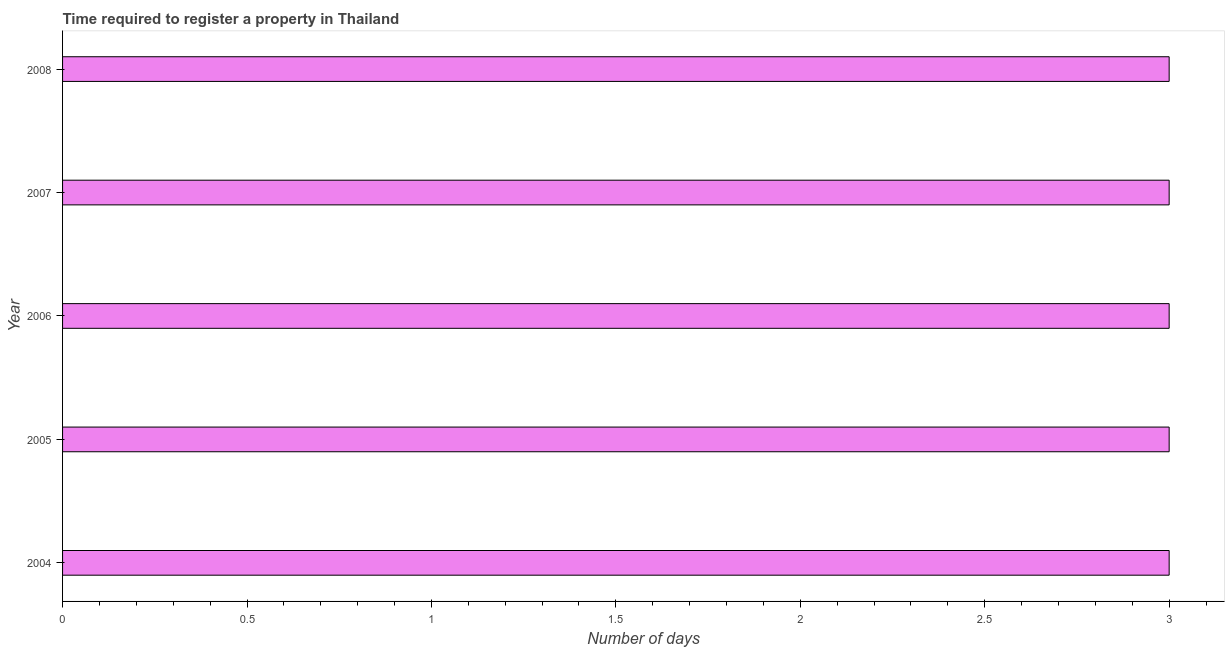What is the title of the graph?
Make the answer very short. Time required to register a property in Thailand. What is the label or title of the X-axis?
Give a very brief answer. Number of days. What is the label or title of the Y-axis?
Offer a very short reply. Year. What is the number of days required to register property in 2006?
Your answer should be compact. 3. Across all years, what is the maximum number of days required to register property?
Ensure brevity in your answer.  3. In which year was the number of days required to register property maximum?
Make the answer very short. 2004. In which year was the number of days required to register property minimum?
Ensure brevity in your answer.  2004. What is the difference between the number of days required to register property in 2005 and 2007?
Your answer should be very brief. 0. What is the median number of days required to register property?
Offer a very short reply. 3. Do a majority of the years between 2007 and 2004 (inclusive) have number of days required to register property greater than 2.8 days?
Keep it short and to the point. Yes. Is the number of days required to register property in 2005 less than that in 2008?
Your answer should be compact. No. Is the difference between the number of days required to register property in 2004 and 2006 greater than the difference between any two years?
Provide a short and direct response. Yes. What is the difference between the highest and the second highest number of days required to register property?
Your answer should be very brief. 0. What is the difference between the highest and the lowest number of days required to register property?
Your answer should be compact. 0. How many years are there in the graph?
Give a very brief answer. 5. What is the difference between two consecutive major ticks on the X-axis?
Offer a very short reply. 0.5. What is the Number of days of 2005?
Your answer should be very brief. 3. What is the Number of days in 2006?
Give a very brief answer. 3. What is the difference between the Number of days in 2005 and 2007?
Your response must be concise. 0. What is the difference between the Number of days in 2005 and 2008?
Provide a short and direct response. 0. What is the ratio of the Number of days in 2004 to that in 2007?
Your answer should be compact. 1. What is the ratio of the Number of days in 2004 to that in 2008?
Offer a very short reply. 1. What is the ratio of the Number of days in 2005 to that in 2006?
Keep it short and to the point. 1. What is the ratio of the Number of days in 2005 to that in 2008?
Make the answer very short. 1. What is the ratio of the Number of days in 2006 to that in 2007?
Give a very brief answer. 1. What is the ratio of the Number of days in 2006 to that in 2008?
Provide a succinct answer. 1. What is the ratio of the Number of days in 2007 to that in 2008?
Keep it short and to the point. 1. 